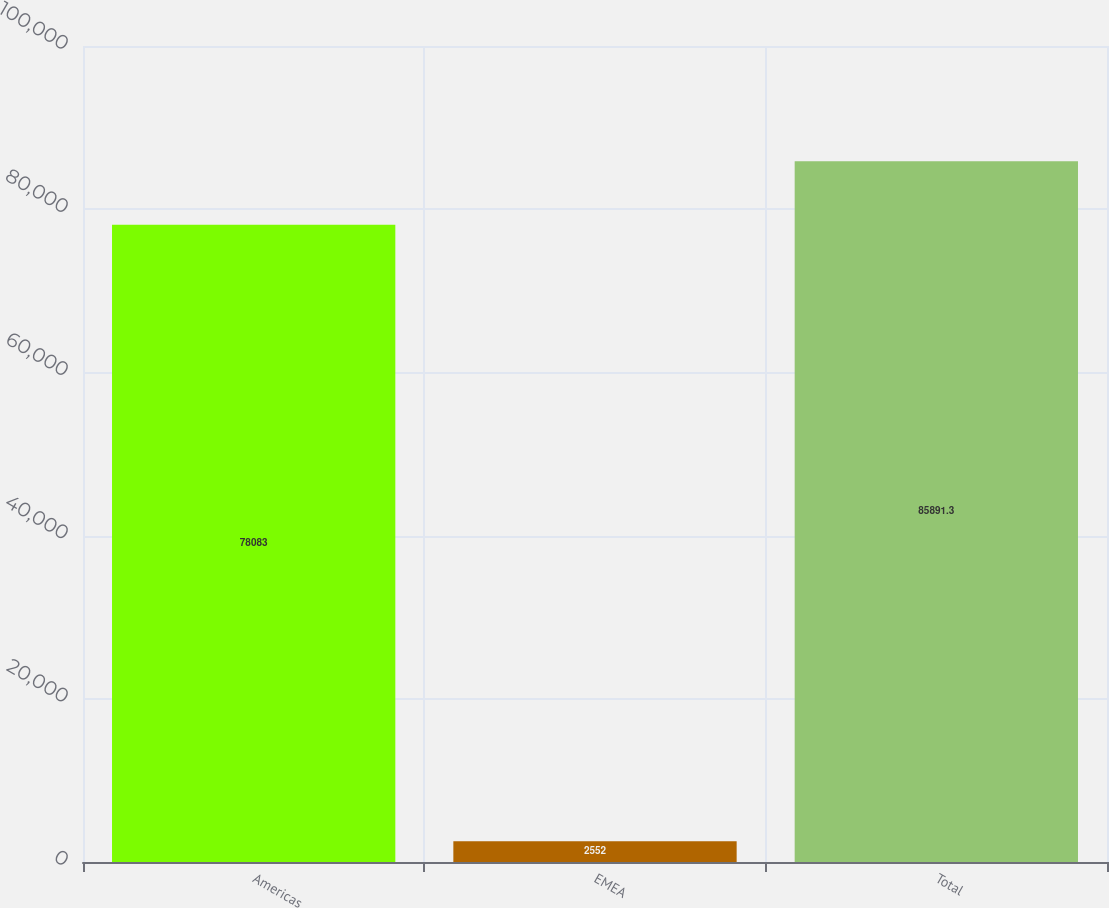Convert chart. <chart><loc_0><loc_0><loc_500><loc_500><bar_chart><fcel>Americas<fcel>EMEA<fcel>Total<nl><fcel>78083<fcel>2552<fcel>85891.3<nl></chart> 